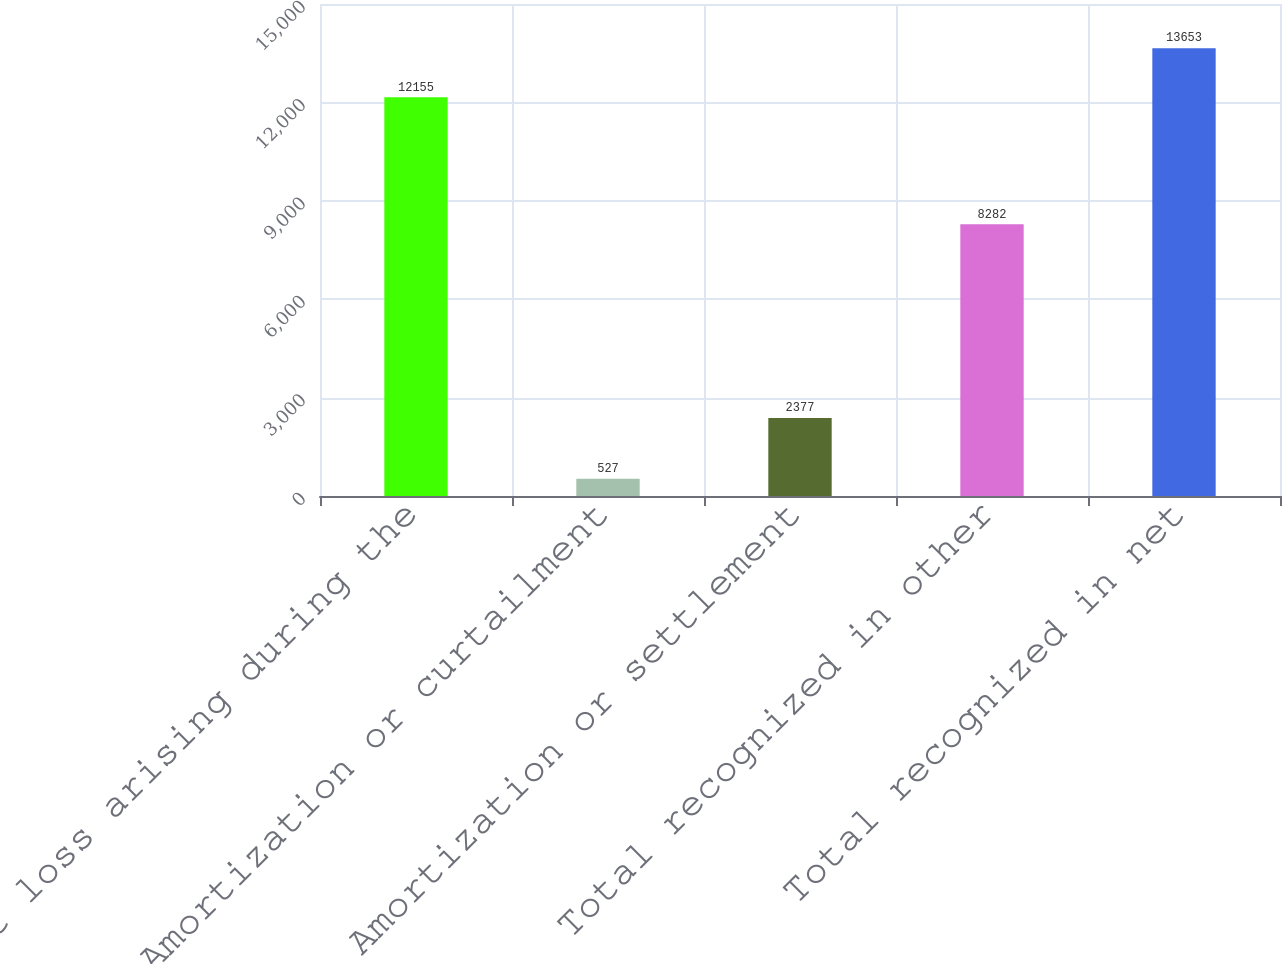Convert chart to OTSL. <chart><loc_0><loc_0><loc_500><loc_500><bar_chart><fcel>Net loss arising during the<fcel>Amortization or curtailment<fcel>Amortization or settlement<fcel>Total recognized in other<fcel>Total recognized in net<nl><fcel>12155<fcel>527<fcel>2377<fcel>8282<fcel>13653<nl></chart> 